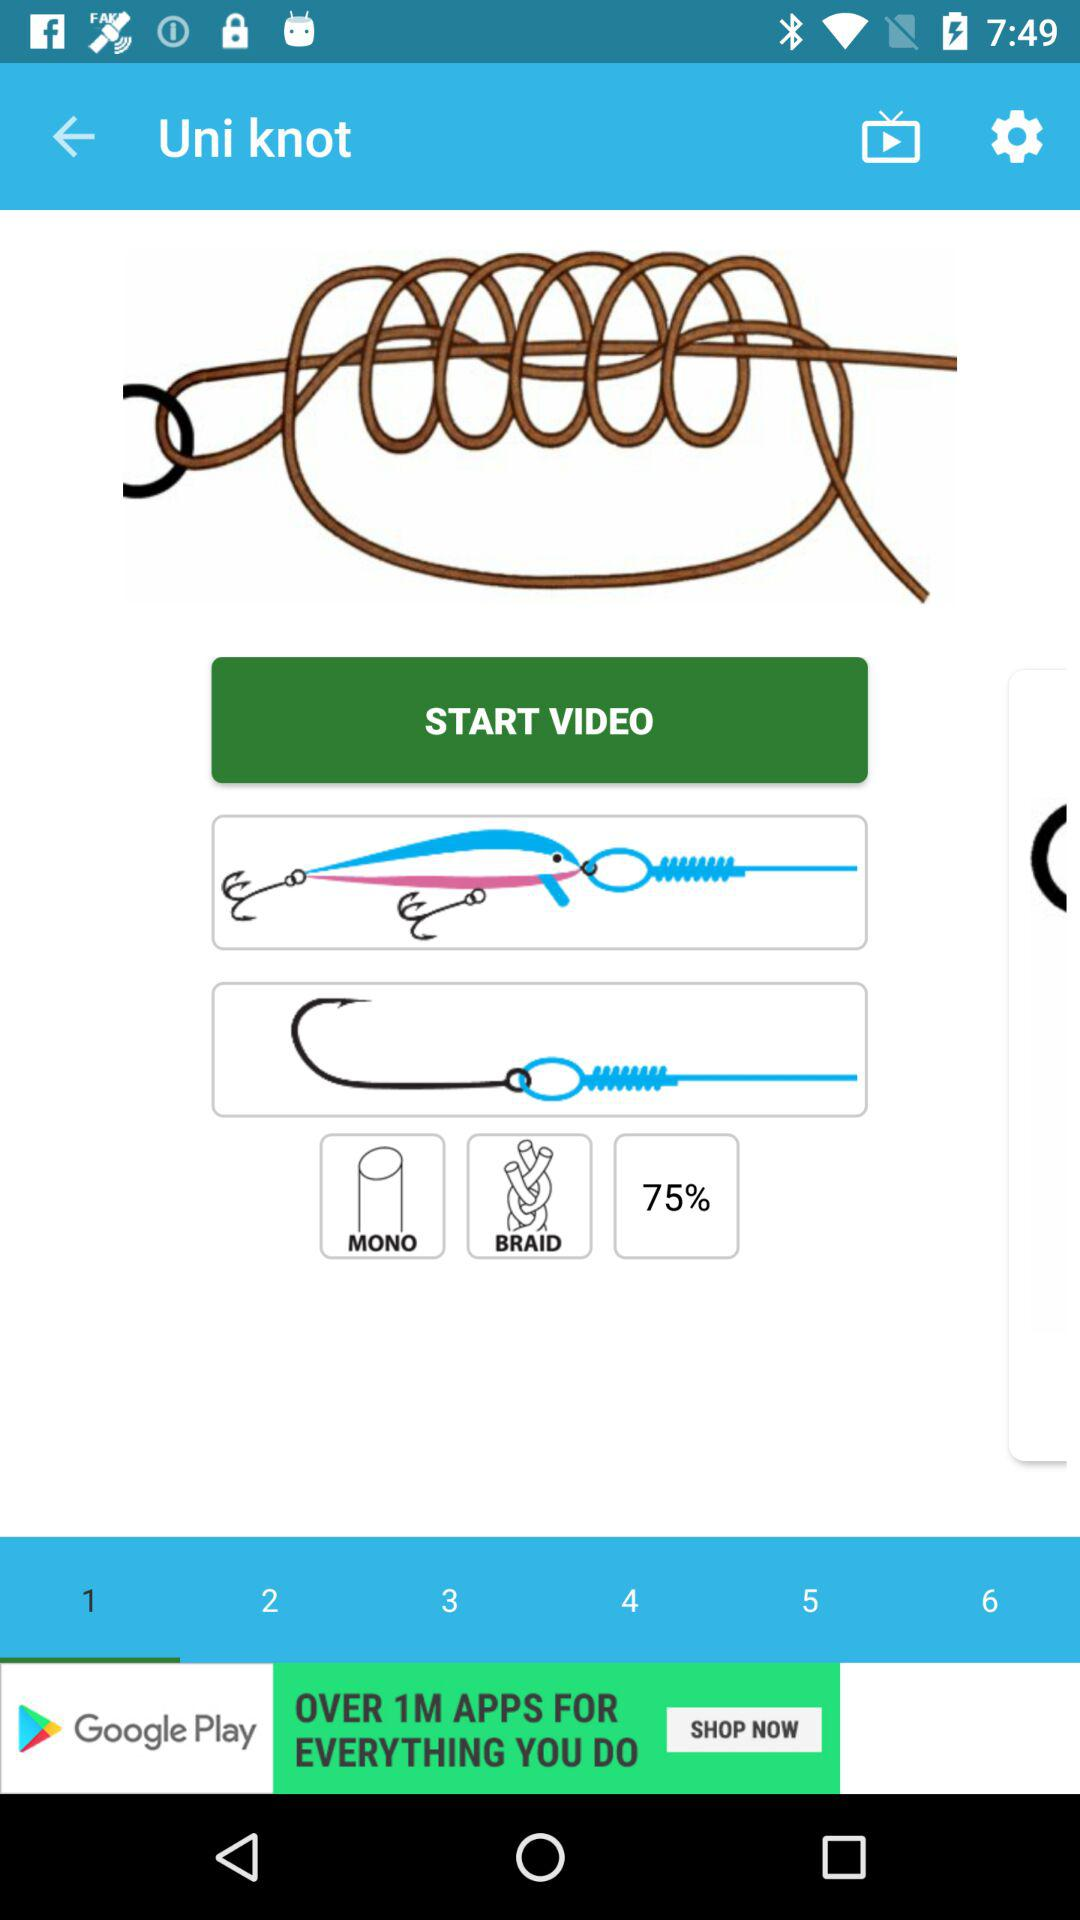How long is the "Uni knot" video?
When the provided information is insufficient, respond with <no answer>. <no answer> 